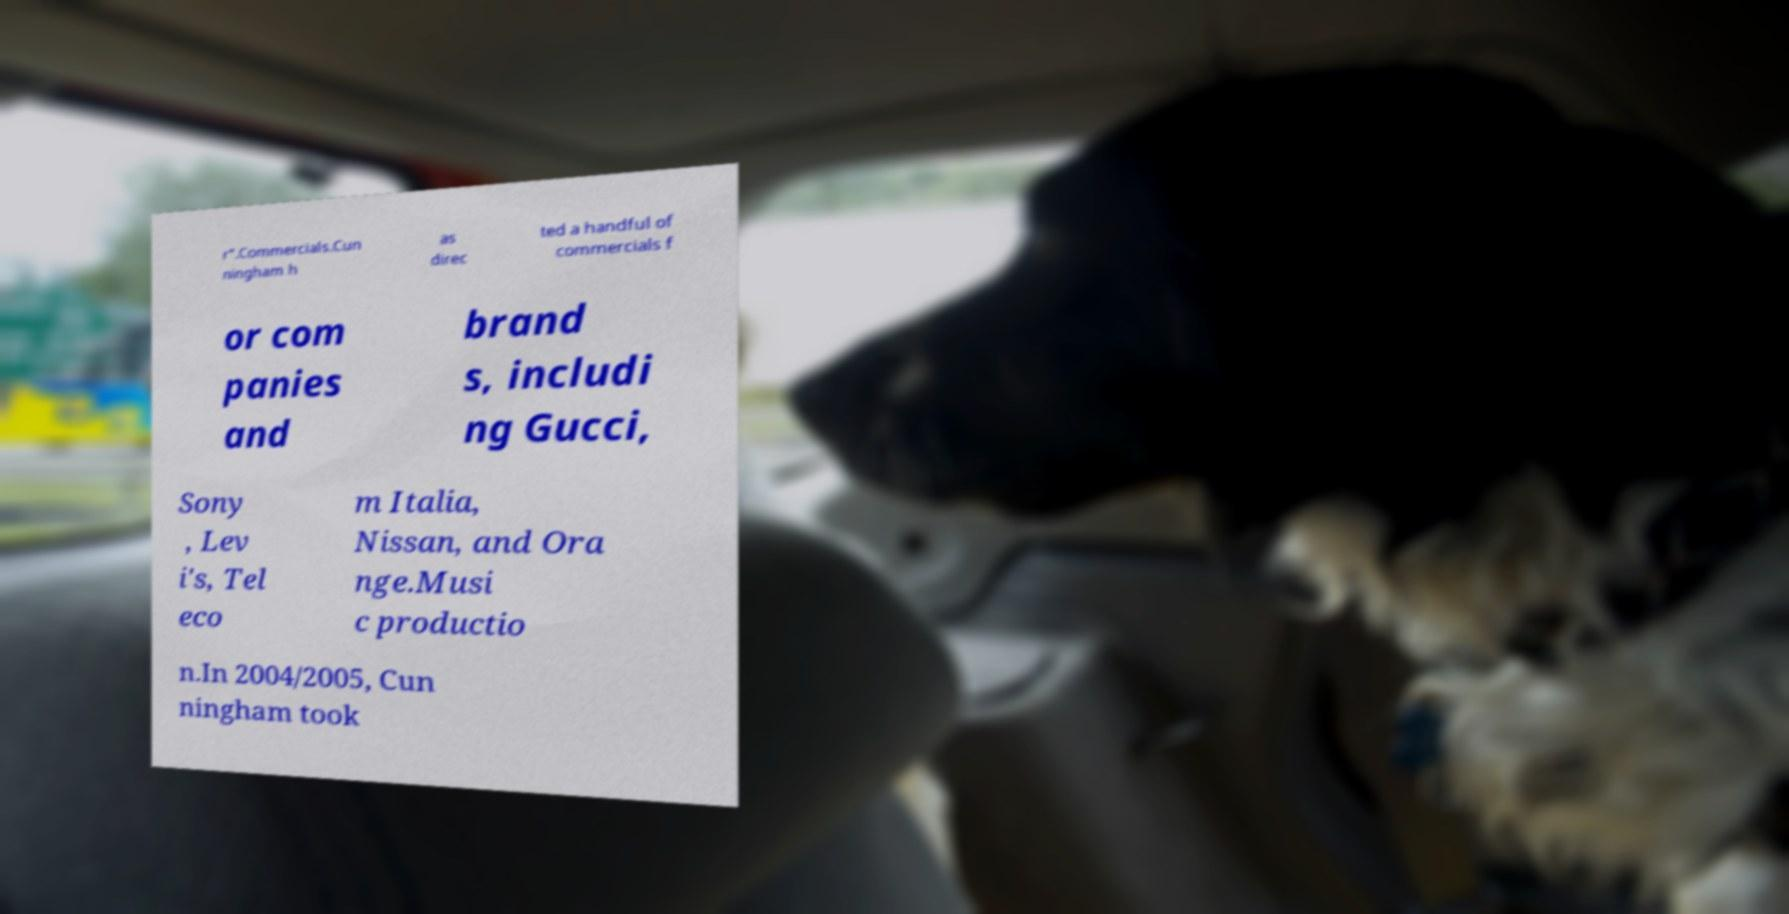For documentation purposes, I need the text within this image transcribed. Could you provide that? r".Commercials.Cun ningham h as direc ted a handful of commercials f or com panies and brand s, includi ng Gucci, Sony , Lev i's, Tel eco m Italia, Nissan, and Ora nge.Musi c productio n.In 2004/2005, Cun ningham took 